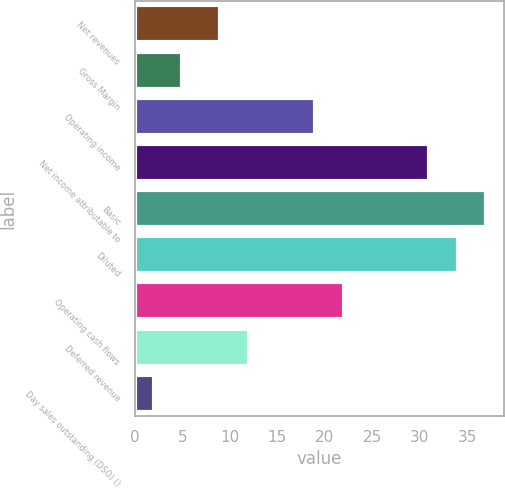<chart> <loc_0><loc_0><loc_500><loc_500><bar_chart><fcel>Net revenues<fcel>Gross Margin<fcel>Operating income<fcel>Net income attributable to<fcel>Basic<fcel>Diluted<fcel>Operating cash flows<fcel>Deferred revenue<fcel>Day sales outstanding (DSO) ()<nl><fcel>9<fcel>5<fcel>19<fcel>31<fcel>37<fcel>34<fcel>22<fcel>12<fcel>2<nl></chart> 